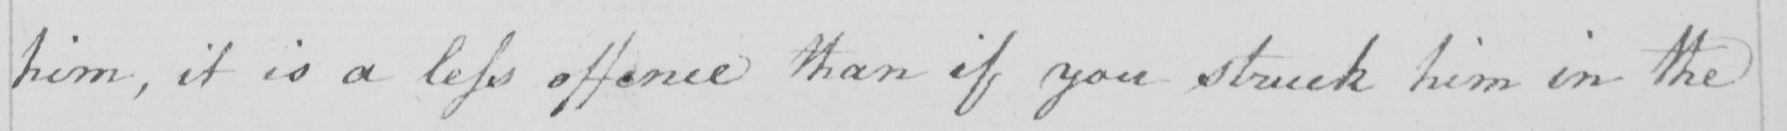Can you read and transcribe this handwriting? him, it is a less offence than if you struck him in the 